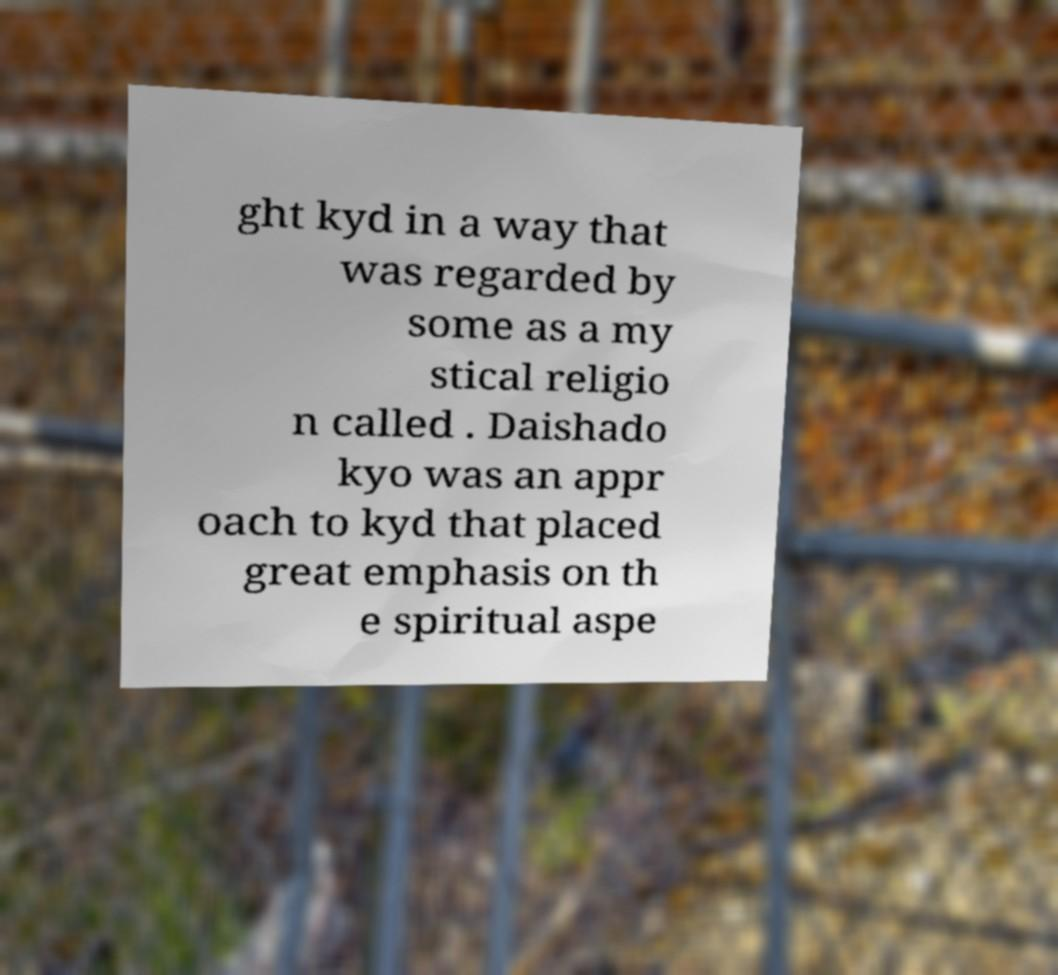There's text embedded in this image that I need extracted. Can you transcribe it verbatim? ght kyd in a way that was regarded by some as a my stical religio n called . Daishado kyo was an appr oach to kyd that placed great emphasis on th e spiritual aspe 